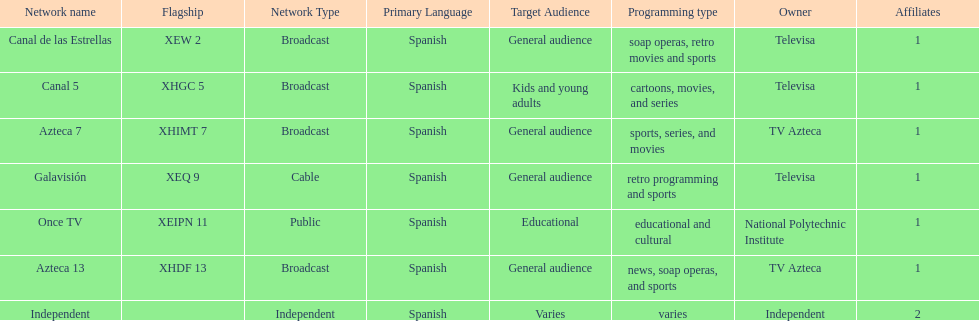How many networks does televisa own? 3. 